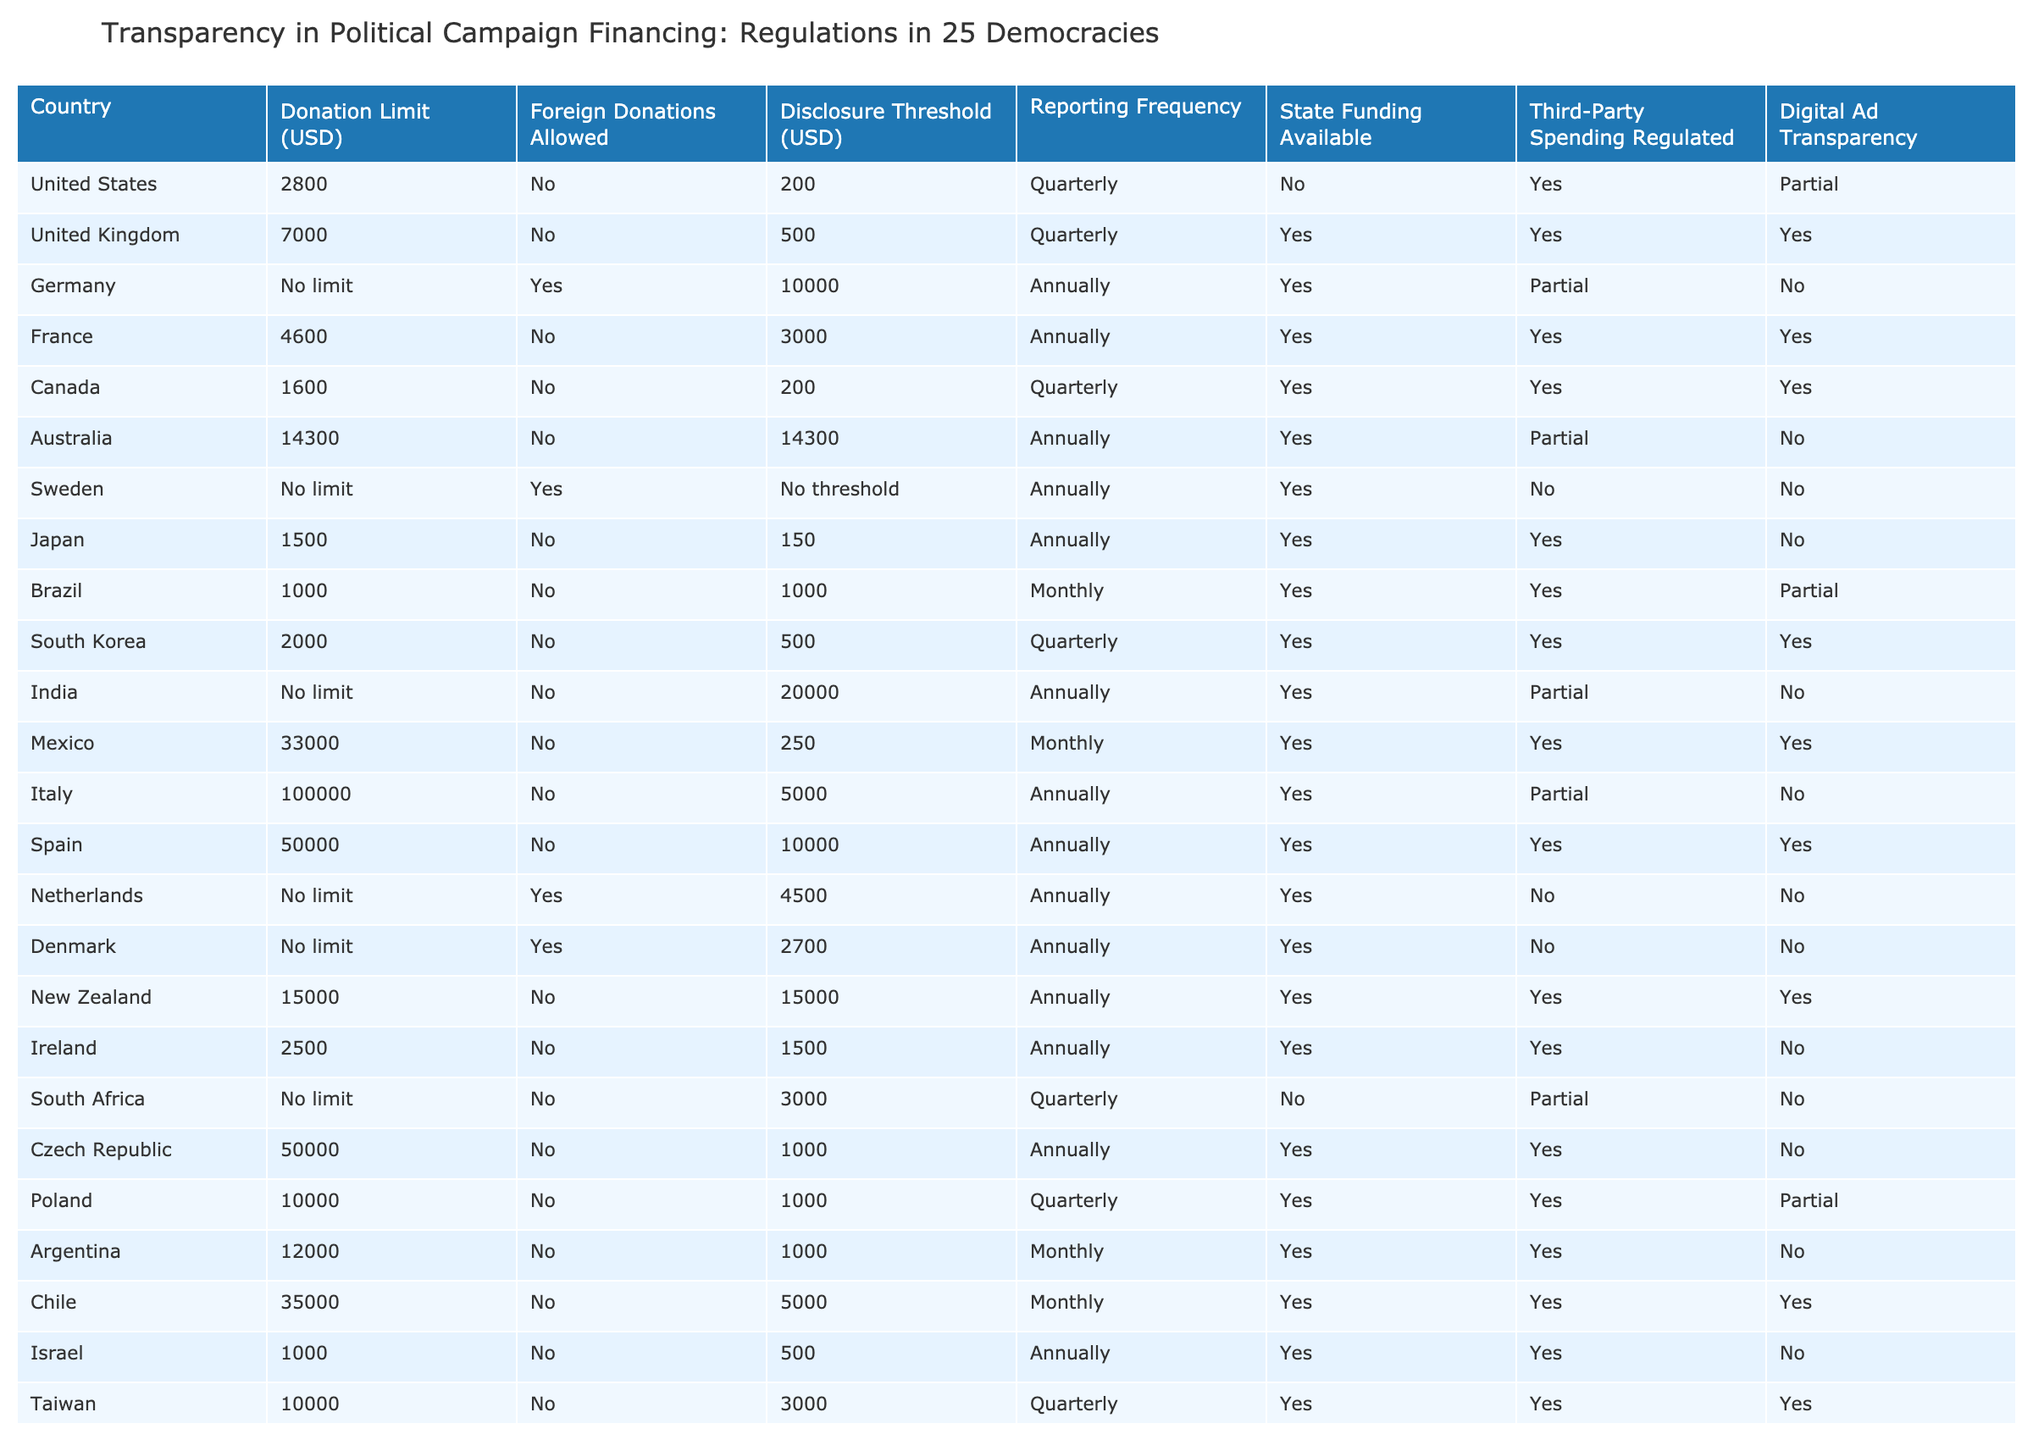What is the donation limit in Italy? The table explicitly states "100000" as the donation limit for Italy.
Answer: 100000 Which countries allow foreign donations? By examining the "Foreign Donations Allowed" column, Germany, Sweden, and the Netherlands are the countries that allow foreign donations, as they are marked with "Yes."
Answer: Germany, Sweden, Netherlands How often do countries with state funding report their campaign finances? Among the countries with state funding (Germany, France, Canada, Australia, India, Mexico, Spain, New Zealand, Czech Republic, Argentina, Taiwan), "Reporting Frequency" is checked for Annual and Quarterly. 7 countries report annually, and 3 report quarterly.
Answer: 7 annually, 3 quarterly Are there any countries that allow foreign donations while having a donation limit? From the table, only Germany allows foreign donations and has no donation limit, as indicated by the respective columns.
Answer: No Which country has the lowest donation limit for political campaigns? Reviewing the "Donation Limit" column, Japan has the lowest limit of "1500," which is lower than all other listed countries.
Answer: 1500 What is the average donation limit for countries that have a defined limit? First, we will sum the defined limits: (2800 + 7000 + 4600 + 1600 + 14300 + 1500 + 1000 + 2000 + 33000 + 100000 + 50000 + 10000 + 12000 + 35000 + 1000 + 10000) = 193,100. Next, we count the total of these countries (14), and divide: 193,100 / 14 = 13,785.71.
Answer: 13785.71 In how many countries is third-party spending regulated? In the table, "Third-Party Spending Regulated" is marked as "Yes" for 13 out of the 25 countries listed.
Answer: 13 Does Canada have a disclosure threshold, and if so, what is it? Checking the "Disclosure Threshold" column, Canada has a threshold marked as "200."
Answer: Yes, 200 What is the reporting frequency for the country with the highest donation limit? Italy has the highest donation limit of "100000," and it also reports its finances annually, as per the "Reporting Frequency" column.
Answer: Annually Which countries do not provide state funding? Upon reviewing the "State Funding Available" column, the countries that do not provide state funding include the United States, South Africa, and Sweden, as they are marked "No."
Answer: United States, South Africa, Sweden 